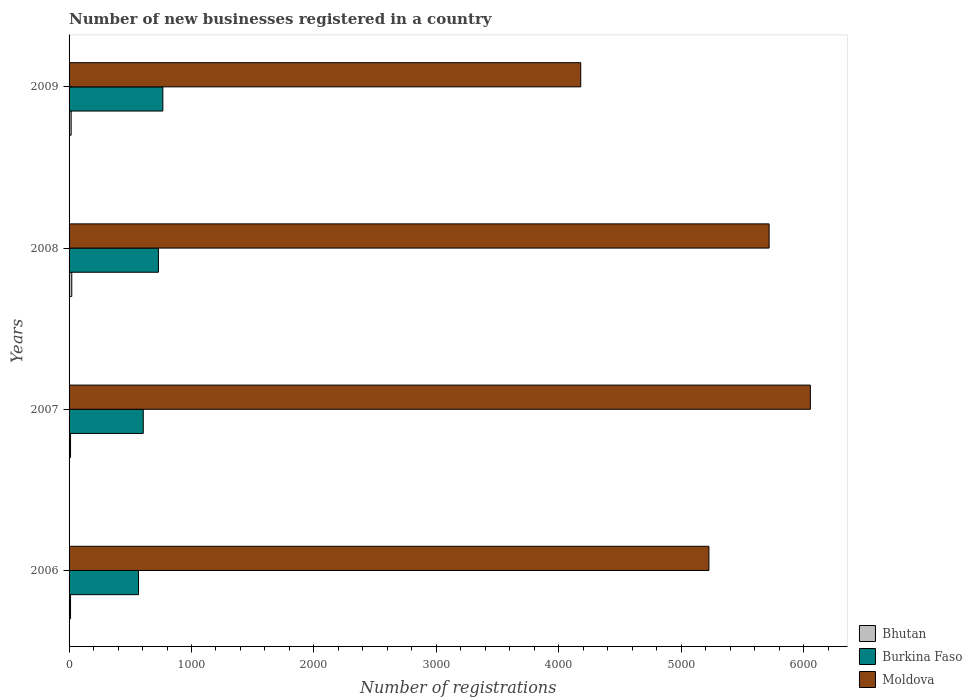How many groups of bars are there?
Keep it short and to the point. 4. Are the number of bars per tick equal to the number of legend labels?
Provide a succinct answer. Yes. How many bars are there on the 2nd tick from the top?
Your response must be concise. 3. What is the number of new businesses registered in Burkina Faso in 2006?
Make the answer very short. 567. Across all years, what is the maximum number of new businesses registered in Moldova?
Provide a succinct answer. 6056. Across all years, what is the minimum number of new businesses registered in Bhutan?
Keep it short and to the point. 12. In which year was the number of new businesses registered in Bhutan maximum?
Ensure brevity in your answer.  2008. What is the total number of new businesses registered in Bhutan in the graph?
Give a very brief answer. 63. What is the difference between the number of new businesses registered in Burkina Faso in 2008 and that in 2009?
Your answer should be very brief. -36. What is the difference between the number of new businesses registered in Bhutan in 2009 and the number of new businesses registered in Burkina Faso in 2007?
Your answer should be very brief. -589. What is the average number of new businesses registered in Moldova per year?
Your response must be concise. 5295.5. In the year 2007, what is the difference between the number of new businesses registered in Burkina Faso and number of new businesses registered in Moldova?
Your answer should be very brief. -5450. In how many years, is the number of new businesses registered in Burkina Faso greater than 4200 ?
Offer a very short reply. 0. What is the ratio of the number of new businesses registered in Moldova in 2008 to that in 2009?
Provide a short and direct response. 1.37. In how many years, is the number of new businesses registered in Bhutan greater than the average number of new businesses registered in Bhutan taken over all years?
Ensure brevity in your answer.  2. What does the 3rd bar from the top in 2008 represents?
Your answer should be very brief. Bhutan. What does the 2nd bar from the bottom in 2007 represents?
Offer a terse response. Burkina Faso. Is it the case that in every year, the sum of the number of new businesses registered in Bhutan and number of new businesses registered in Burkina Faso is greater than the number of new businesses registered in Moldova?
Provide a short and direct response. No. Are all the bars in the graph horizontal?
Your answer should be very brief. Yes. Does the graph contain grids?
Your answer should be very brief. No. What is the title of the graph?
Ensure brevity in your answer.  Number of new businesses registered in a country. What is the label or title of the X-axis?
Give a very brief answer. Number of registrations. What is the Number of registrations of Bhutan in 2006?
Your response must be concise. 12. What is the Number of registrations in Burkina Faso in 2006?
Your response must be concise. 567. What is the Number of registrations in Moldova in 2006?
Your response must be concise. 5227. What is the Number of registrations in Burkina Faso in 2007?
Provide a short and direct response. 606. What is the Number of registrations of Moldova in 2007?
Offer a very short reply. 6056. What is the Number of registrations of Bhutan in 2008?
Provide a succinct answer. 22. What is the Number of registrations in Burkina Faso in 2008?
Your response must be concise. 730. What is the Number of registrations in Moldova in 2008?
Make the answer very short. 5719. What is the Number of registrations in Burkina Faso in 2009?
Give a very brief answer. 766. What is the Number of registrations of Moldova in 2009?
Offer a very short reply. 4180. Across all years, what is the maximum Number of registrations of Burkina Faso?
Make the answer very short. 766. Across all years, what is the maximum Number of registrations of Moldova?
Your answer should be compact. 6056. Across all years, what is the minimum Number of registrations in Burkina Faso?
Offer a terse response. 567. Across all years, what is the minimum Number of registrations of Moldova?
Offer a very short reply. 4180. What is the total Number of registrations of Burkina Faso in the graph?
Your response must be concise. 2669. What is the total Number of registrations of Moldova in the graph?
Ensure brevity in your answer.  2.12e+04. What is the difference between the Number of registrations of Bhutan in 2006 and that in 2007?
Your answer should be very brief. 0. What is the difference between the Number of registrations in Burkina Faso in 2006 and that in 2007?
Make the answer very short. -39. What is the difference between the Number of registrations of Moldova in 2006 and that in 2007?
Keep it short and to the point. -829. What is the difference between the Number of registrations in Burkina Faso in 2006 and that in 2008?
Ensure brevity in your answer.  -163. What is the difference between the Number of registrations of Moldova in 2006 and that in 2008?
Your response must be concise. -492. What is the difference between the Number of registrations of Burkina Faso in 2006 and that in 2009?
Your answer should be compact. -199. What is the difference between the Number of registrations in Moldova in 2006 and that in 2009?
Ensure brevity in your answer.  1047. What is the difference between the Number of registrations in Burkina Faso in 2007 and that in 2008?
Your answer should be very brief. -124. What is the difference between the Number of registrations of Moldova in 2007 and that in 2008?
Your answer should be compact. 337. What is the difference between the Number of registrations of Bhutan in 2007 and that in 2009?
Make the answer very short. -5. What is the difference between the Number of registrations of Burkina Faso in 2007 and that in 2009?
Give a very brief answer. -160. What is the difference between the Number of registrations of Moldova in 2007 and that in 2009?
Offer a very short reply. 1876. What is the difference between the Number of registrations in Bhutan in 2008 and that in 2009?
Offer a very short reply. 5. What is the difference between the Number of registrations of Burkina Faso in 2008 and that in 2009?
Provide a short and direct response. -36. What is the difference between the Number of registrations of Moldova in 2008 and that in 2009?
Your answer should be compact. 1539. What is the difference between the Number of registrations of Bhutan in 2006 and the Number of registrations of Burkina Faso in 2007?
Your answer should be compact. -594. What is the difference between the Number of registrations in Bhutan in 2006 and the Number of registrations in Moldova in 2007?
Provide a short and direct response. -6044. What is the difference between the Number of registrations in Burkina Faso in 2006 and the Number of registrations in Moldova in 2007?
Provide a short and direct response. -5489. What is the difference between the Number of registrations in Bhutan in 2006 and the Number of registrations in Burkina Faso in 2008?
Ensure brevity in your answer.  -718. What is the difference between the Number of registrations in Bhutan in 2006 and the Number of registrations in Moldova in 2008?
Make the answer very short. -5707. What is the difference between the Number of registrations in Burkina Faso in 2006 and the Number of registrations in Moldova in 2008?
Your response must be concise. -5152. What is the difference between the Number of registrations in Bhutan in 2006 and the Number of registrations in Burkina Faso in 2009?
Make the answer very short. -754. What is the difference between the Number of registrations in Bhutan in 2006 and the Number of registrations in Moldova in 2009?
Offer a very short reply. -4168. What is the difference between the Number of registrations of Burkina Faso in 2006 and the Number of registrations of Moldova in 2009?
Your response must be concise. -3613. What is the difference between the Number of registrations in Bhutan in 2007 and the Number of registrations in Burkina Faso in 2008?
Ensure brevity in your answer.  -718. What is the difference between the Number of registrations in Bhutan in 2007 and the Number of registrations in Moldova in 2008?
Offer a terse response. -5707. What is the difference between the Number of registrations of Burkina Faso in 2007 and the Number of registrations of Moldova in 2008?
Your answer should be compact. -5113. What is the difference between the Number of registrations of Bhutan in 2007 and the Number of registrations of Burkina Faso in 2009?
Your answer should be compact. -754. What is the difference between the Number of registrations in Bhutan in 2007 and the Number of registrations in Moldova in 2009?
Offer a terse response. -4168. What is the difference between the Number of registrations in Burkina Faso in 2007 and the Number of registrations in Moldova in 2009?
Offer a terse response. -3574. What is the difference between the Number of registrations of Bhutan in 2008 and the Number of registrations of Burkina Faso in 2009?
Ensure brevity in your answer.  -744. What is the difference between the Number of registrations in Bhutan in 2008 and the Number of registrations in Moldova in 2009?
Ensure brevity in your answer.  -4158. What is the difference between the Number of registrations in Burkina Faso in 2008 and the Number of registrations in Moldova in 2009?
Ensure brevity in your answer.  -3450. What is the average Number of registrations in Bhutan per year?
Make the answer very short. 15.75. What is the average Number of registrations of Burkina Faso per year?
Offer a terse response. 667.25. What is the average Number of registrations in Moldova per year?
Give a very brief answer. 5295.5. In the year 2006, what is the difference between the Number of registrations of Bhutan and Number of registrations of Burkina Faso?
Provide a succinct answer. -555. In the year 2006, what is the difference between the Number of registrations in Bhutan and Number of registrations in Moldova?
Your answer should be compact. -5215. In the year 2006, what is the difference between the Number of registrations of Burkina Faso and Number of registrations of Moldova?
Ensure brevity in your answer.  -4660. In the year 2007, what is the difference between the Number of registrations of Bhutan and Number of registrations of Burkina Faso?
Your response must be concise. -594. In the year 2007, what is the difference between the Number of registrations of Bhutan and Number of registrations of Moldova?
Keep it short and to the point. -6044. In the year 2007, what is the difference between the Number of registrations in Burkina Faso and Number of registrations in Moldova?
Your answer should be very brief. -5450. In the year 2008, what is the difference between the Number of registrations in Bhutan and Number of registrations in Burkina Faso?
Offer a very short reply. -708. In the year 2008, what is the difference between the Number of registrations of Bhutan and Number of registrations of Moldova?
Your answer should be compact. -5697. In the year 2008, what is the difference between the Number of registrations of Burkina Faso and Number of registrations of Moldova?
Provide a short and direct response. -4989. In the year 2009, what is the difference between the Number of registrations of Bhutan and Number of registrations of Burkina Faso?
Offer a terse response. -749. In the year 2009, what is the difference between the Number of registrations of Bhutan and Number of registrations of Moldova?
Keep it short and to the point. -4163. In the year 2009, what is the difference between the Number of registrations in Burkina Faso and Number of registrations in Moldova?
Your response must be concise. -3414. What is the ratio of the Number of registrations in Bhutan in 2006 to that in 2007?
Your answer should be very brief. 1. What is the ratio of the Number of registrations in Burkina Faso in 2006 to that in 2007?
Keep it short and to the point. 0.94. What is the ratio of the Number of registrations of Moldova in 2006 to that in 2007?
Your answer should be very brief. 0.86. What is the ratio of the Number of registrations of Bhutan in 2006 to that in 2008?
Provide a succinct answer. 0.55. What is the ratio of the Number of registrations of Burkina Faso in 2006 to that in 2008?
Give a very brief answer. 0.78. What is the ratio of the Number of registrations in Moldova in 2006 to that in 2008?
Ensure brevity in your answer.  0.91. What is the ratio of the Number of registrations in Bhutan in 2006 to that in 2009?
Make the answer very short. 0.71. What is the ratio of the Number of registrations in Burkina Faso in 2006 to that in 2009?
Your response must be concise. 0.74. What is the ratio of the Number of registrations in Moldova in 2006 to that in 2009?
Your answer should be compact. 1.25. What is the ratio of the Number of registrations in Bhutan in 2007 to that in 2008?
Provide a short and direct response. 0.55. What is the ratio of the Number of registrations in Burkina Faso in 2007 to that in 2008?
Provide a succinct answer. 0.83. What is the ratio of the Number of registrations in Moldova in 2007 to that in 2008?
Provide a succinct answer. 1.06. What is the ratio of the Number of registrations in Bhutan in 2007 to that in 2009?
Give a very brief answer. 0.71. What is the ratio of the Number of registrations in Burkina Faso in 2007 to that in 2009?
Your response must be concise. 0.79. What is the ratio of the Number of registrations in Moldova in 2007 to that in 2009?
Your answer should be very brief. 1.45. What is the ratio of the Number of registrations of Bhutan in 2008 to that in 2009?
Offer a terse response. 1.29. What is the ratio of the Number of registrations in Burkina Faso in 2008 to that in 2009?
Offer a terse response. 0.95. What is the ratio of the Number of registrations in Moldova in 2008 to that in 2009?
Your answer should be very brief. 1.37. What is the difference between the highest and the second highest Number of registrations in Burkina Faso?
Make the answer very short. 36. What is the difference between the highest and the second highest Number of registrations in Moldova?
Give a very brief answer. 337. What is the difference between the highest and the lowest Number of registrations in Bhutan?
Offer a terse response. 10. What is the difference between the highest and the lowest Number of registrations in Burkina Faso?
Offer a terse response. 199. What is the difference between the highest and the lowest Number of registrations of Moldova?
Keep it short and to the point. 1876. 